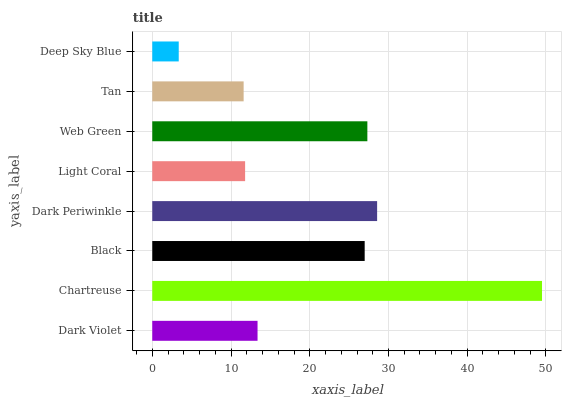Is Deep Sky Blue the minimum?
Answer yes or no. Yes. Is Chartreuse the maximum?
Answer yes or no. Yes. Is Black the minimum?
Answer yes or no. No. Is Black the maximum?
Answer yes or no. No. Is Chartreuse greater than Black?
Answer yes or no. Yes. Is Black less than Chartreuse?
Answer yes or no. Yes. Is Black greater than Chartreuse?
Answer yes or no. No. Is Chartreuse less than Black?
Answer yes or no. No. Is Black the high median?
Answer yes or no. Yes. Is Dark Violet the low median?
Answer yes or no. Yes. Is Web Green the high median?
Answer yes or no. No. Is Tan the low median?
Answer yes or no. No. 